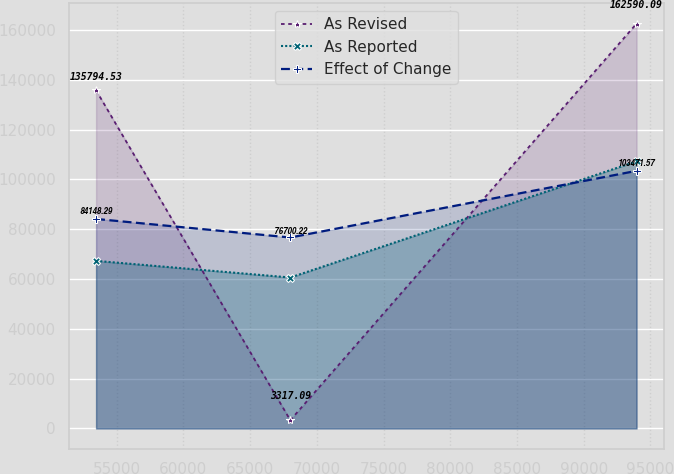<chart> <loc_0><loc_0><loc_500><loc_500><line_chart><ecel><fcel>As Revised<fcel>As Reported<fcel>Effect of Change<nl><fcel>53463.5<fcel>135795<fcel>67315.2<fcel>84148.3<nl><fcel>68017.3<fcel>3317.09<fcel>60627.5<fcel>76700.2<nl><fcel>93958<fcel>162590<fcel>107293<fcel>103472<nl></chart> 